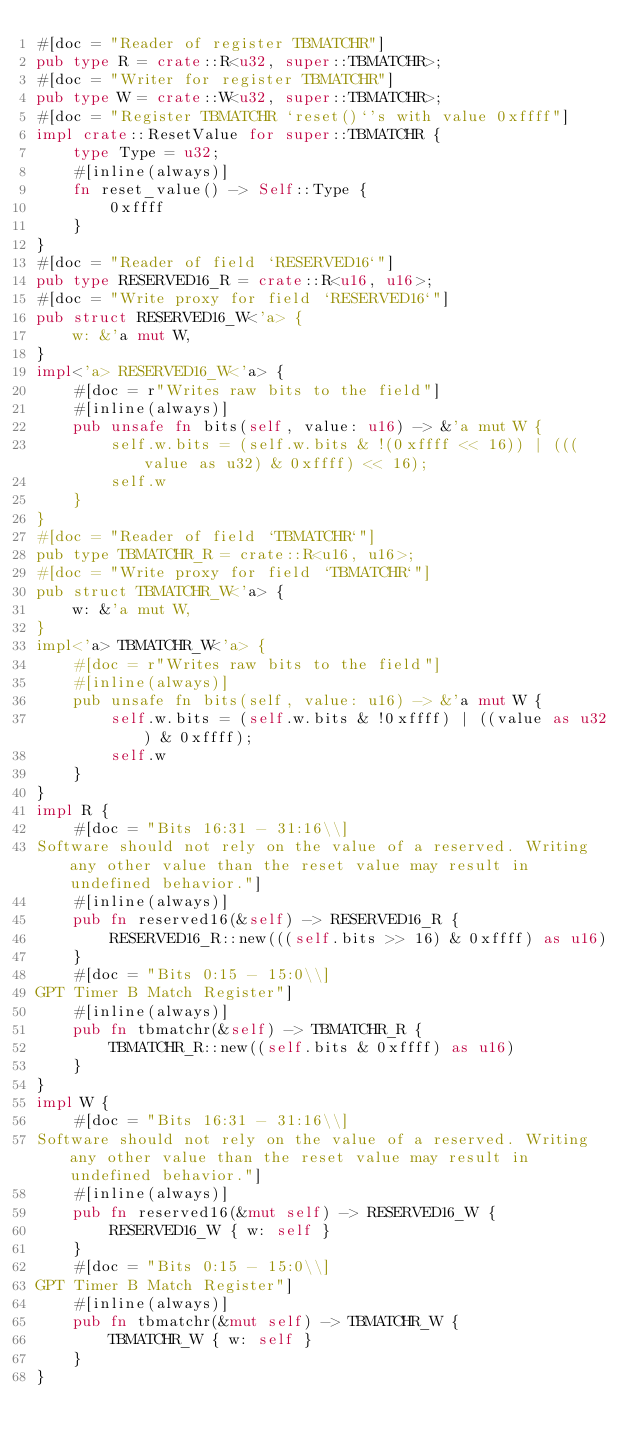<code> <loc_0><loc_0><loc_500><loc_500><_Rust_>#[doc = "Reader of register TBMATCHR"]
pub type R = crate::R<u32, super::TBMATCHR>;
#[doc = "Writer for register TBMATCHR"]
pub type W = crate::W<u32, super::TBMATCHR>;
#[doc = "Register TBMATCHR `reset()`'s with value 0xffff"]
impl crate::ResetValue for super::TBMATCHR {
    type Type = u32;
    #[inline(always)]
    fn reset_value() -> Self::Type {
        0xffff
    }
}
#[doc = "Reader of field `RESERVED16`"]
pub type RESERVED16_R = crate::R<u16, u16>;
#[doc = "Write proxy for field `RESERVED16`"]
pub struct RESERVED16_W<'a> {
    w: &'a mut W,
}
impl<'a> RESERVED16_W<'a> {
    #[doc = r"Writes raw bits to the field"]
    #[inline(always)]
    pub unsafe fn bits(self, value: u16) -> &'a mut W {
        self.w.bits = (self.w.bits & !(0xffff << 16)) | (((value as u32) & 0xffff) << 16);
        self.w
    }
}
#[doc = "Reader of field `TBMATCHR`"]
pub type TBMATCHR_R = crate::R<u16, u16>;
#[doc = "Write proxy for field `TBMATCHR`"]
pub struct TBMATCHR_W<'a> {
    w: &'a mut W,
}
impl<'a> TBMATCHR_W<'a> {
    #[doc = r"Writes raw bits to the field"]
    #[inline(always)]
    pub unsafe fn bits(self, value: u16) -> &'a mut W {
        self.w.bits = (self.w.bits & !0xffff) | ((value as u32) & 0xffff);
        self.w
    }
}
impl R {
    #[doc = "Bits 16:31 - 31:16\\]
Software should not rely on the value of a reserved. Writing any other value than the reset value may result in undefined behavior."]
    #[inline(always)]
    pub fn reserved16(&self) -> RESERVED16_R {
        RESERVED16_R::new(((self.bits >> 16) & 0xffff) as u16)
    }
    #[doc = "Bits 0:15 - 15:0\\]
GPT Timer B Match Register"]
    #[inline(always)]
    pub fn tbmatchr(&self) -> TBMATCHR_R {
        TBMATCHR_R::new((self.bits & 0xffff) as u16)
    }
}
impl W {
    #[doc = "Bits 16:31 - 31:16\\]
Software should not rely on the value of a reserved. Writing any other value than the reset value may result in undefined behavior."]
    #[inline(always)]
    pub fn reserved16(&mut self) -> RESERVED16_W {
        RESERVED16_W { w: self }
    }
    #[doc = "Bits 0:15 - 15:0\\]
GPT Timer B Match Register"]
    #[inline(always)]
    pub fn tbmatchr(&mut self) -> TBMATCHR_W {
        TBMATCHR_W { w: self }
    }
}
</code> 